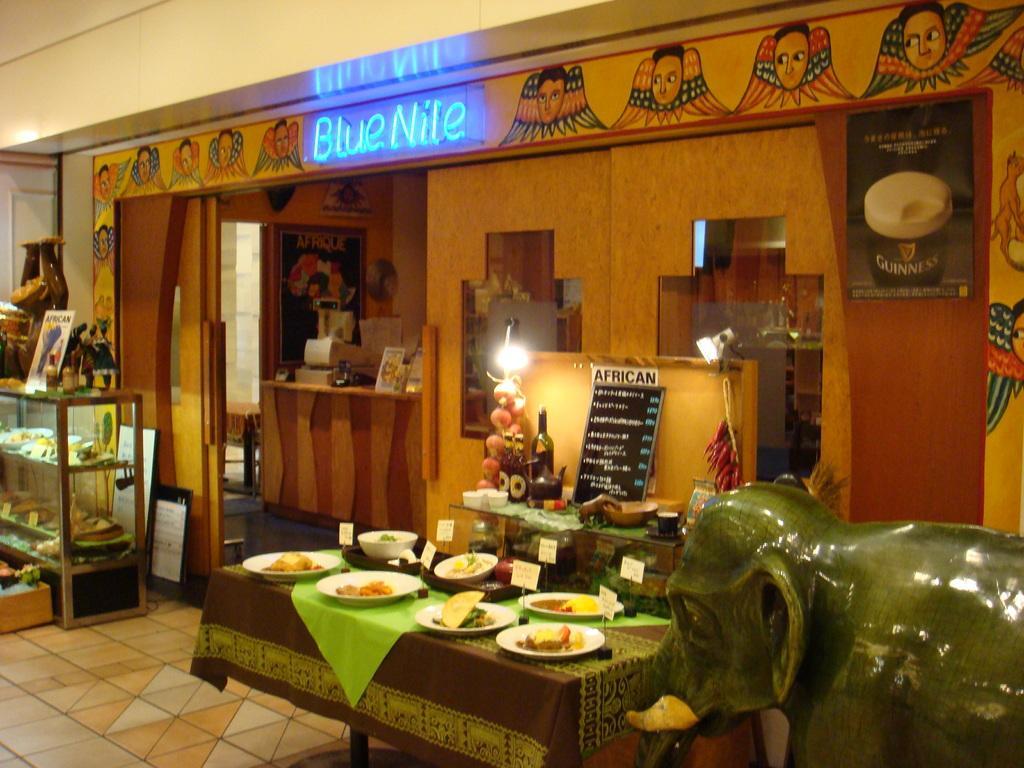Describe this image in one or two sentences. On the right side there is a statue of an elephant. Near to that there is a table with tablecloth. On that there are many plates with food items and tags. Near to that there is another table. On that there is a bottle, kettle, cup, saucer, name board and many other things. Near to that there is a wall with lights. On the left side there is a cupboard with racks. Inside that there are many items. On top of that there are bottles, toys and many other things. In the back there is wall with something written on that. Also there are paintings. There is a poster on the wall. In the back there is a platform. On that there are many things. Near to that there is a wall with a photo frame. 